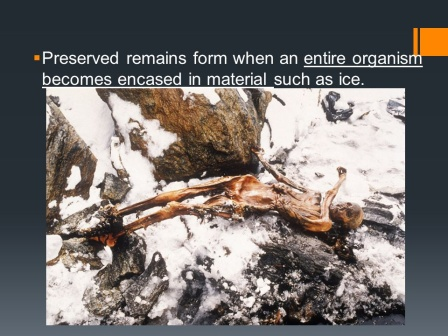What can you infer about the climatic conditions of this place from the image? The image suggests a location with extremely cold climatic conditions, given the presence of ice and snow patches covering the rugged terrain. The fact that the organism became encased in ice indicates a consistently low temperature environment, likely one where the ground remains frozen almost year-round, such as a polar or high-altitude region. Could this skeleton be indicative of a historical civilization? The skeleton might indeed provide clues about past human civilizations, especially if found in conjunction with artifacts or tools characteristic of human activity. The state of preservation can offer valuable insights into the living conditions, causes of death, and physical features of humans from that era. If it is part of an archaeological site, it could significantly contribute to our understanding of ancient human migration and survival in extreme environments. Imagine this skeleton belonged to someone significantly important in history and tell me a detailed story. In a time lost to history, this skeletal figure was once a revered chieftain named Torvald, leader of a resilient tribe called the Northern Wanderers. They lived in an age where endless winters blanketed the world in a shroud of ice and snow. Torvald led his people through some of the harshest conditions known to humanity, his wisdom and courage becoming legendary. One fateful day, foreseeing the encroaching doom of an unending frost, he set out on a perilous journey to find a mythic source of warmth that legends spoke of—a heart of flame hidden deep within the mountains. His quest took him to this unforgiving land, where he encountered treacherous cliffs, ferocious predators, and the relentless cold. Alone and on the brink of death, he was ambushed by a violent blizzard, his body succumbing to the ice, preserved for millennia. The tribe, believing he had become a guardian of the frost, revered his frozen remains, leaving offerings of primitive sculptures and tools around his final resting place. His legacy endured as stories of his bravery were passed down through generations, making him a symbol of indomitable spirit against nature's fiercest odds. 